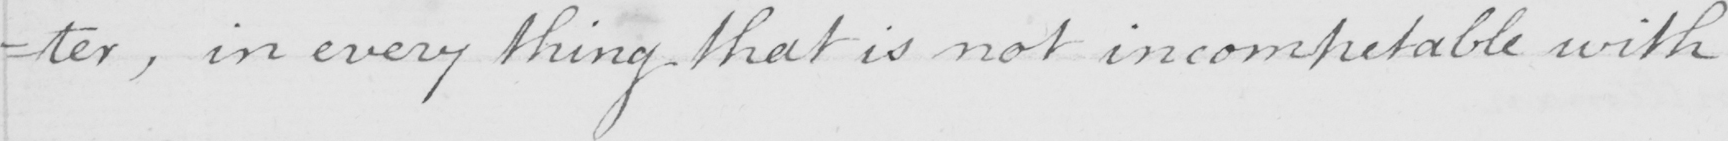What text is written in this handwritten line? =ter , in every thing that is not incompetable with 